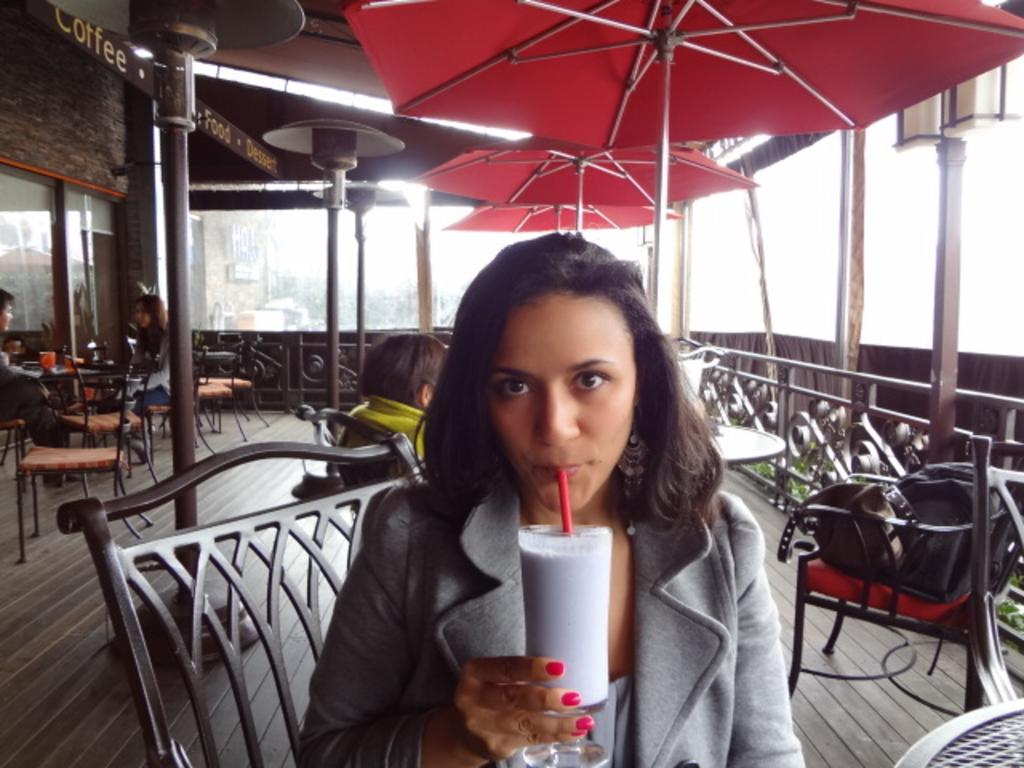Who is present in the image? There is a woman in the image. What is the woman doing in the image? The woman is sitting on a chair and drinking. What can be seen in the background of the image? There are tables and chairs in the background of the image. How many people are sitting on chairs in the background? There are two persons sitting on chairs in the background of the image. What type of fowl can be seen walking around the woman in the image? There are no fowl present in the image; it only features a woman sitting on a chair and drinking. How many pigs are visible in the image? There are no pigs present in the image. 